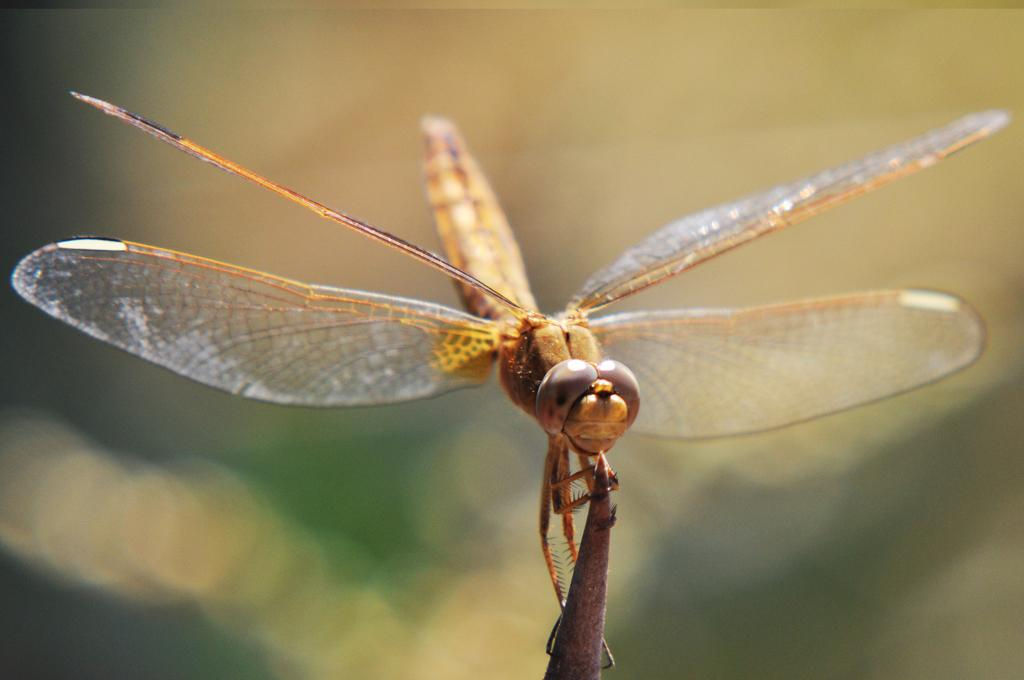What is the general appearance of the background in the image? The background of the image is blurred. What is the main subject of the image? There is a dragonfly in the image. What is the dragonfly doing in the image? The dragonfly is holding an object. What type of destruction is the dragonfly causing in the image? There is no destruction depicted in the image; it features a dragonfly holding an object. What type of work is the dragonfly performing in the image? There is no indication of the dragonfly performing any work in the image. 